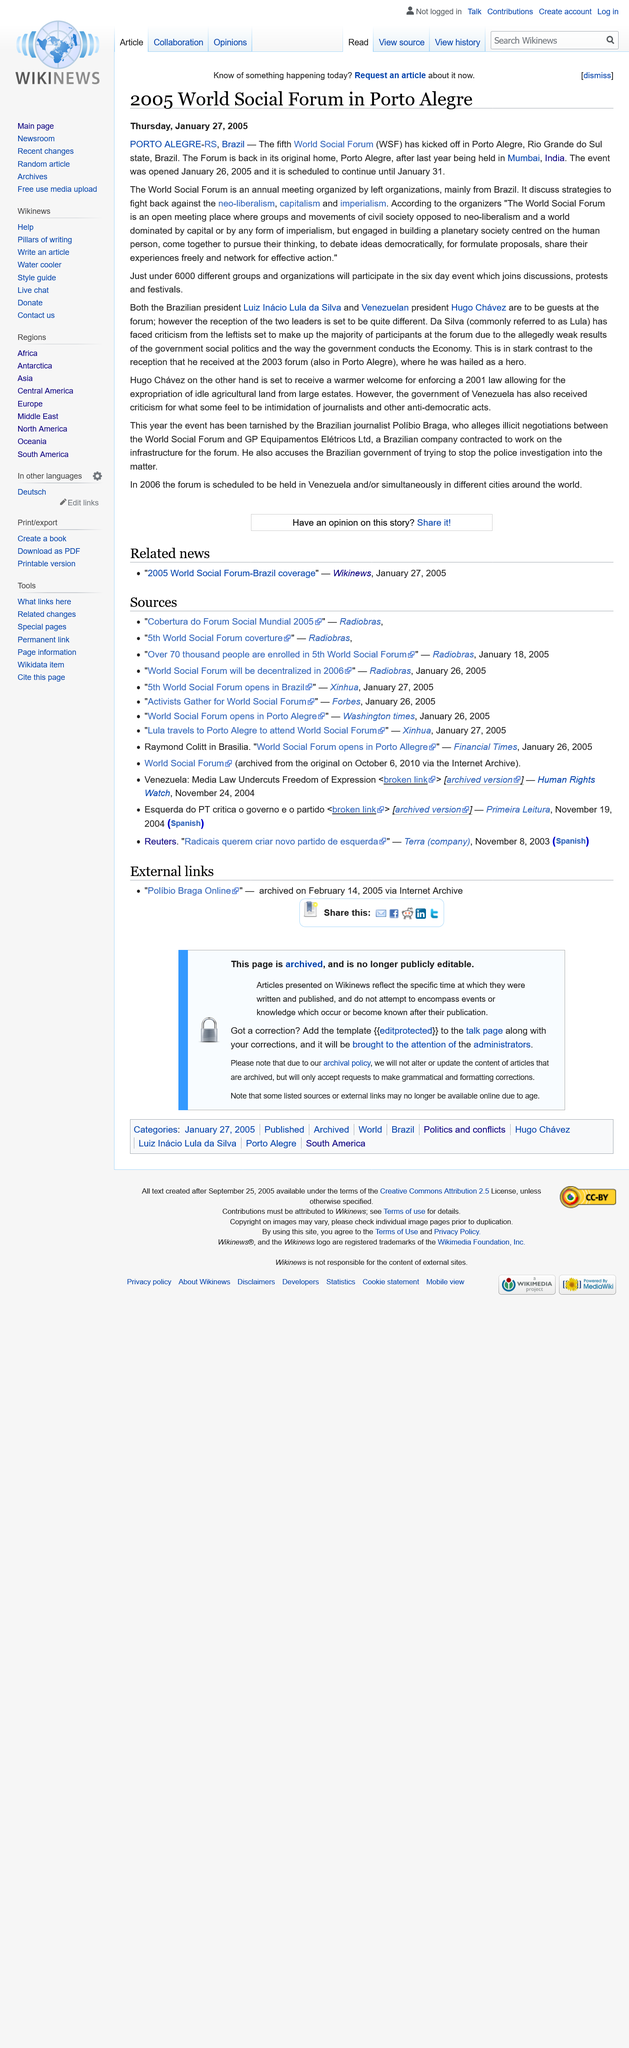Highlight a few significant elements in this photo. The World Social Forum, an event, took place. This article was published on January 27, 2005. The event will take place in Porto Alegre. 